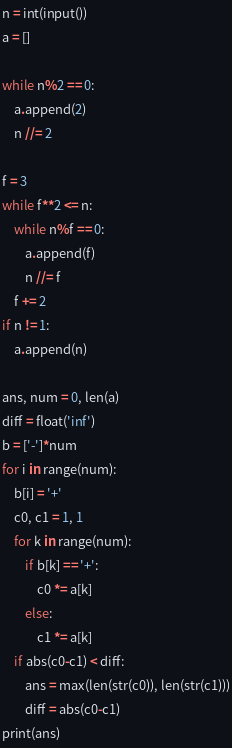<code> <loc_0><loc_0><loc_500><loc_500><_Python_>n = int(input())
a = []

while n%2 == 0:
    a.append(2)
    n //= 2

f = 3
while f**2 <= n:
    while n%f == 0:
        a.append(f)
        n //= f
    f += 2
if n != 1:
    a.append(n)

ans, num = 0, len(a)
diff = float('inf')
b = ['-']*num
for i in range(num):
    b[i] = '+'
    c0, c1 = 1, 1
    for k in range(num):
        if b[k] == '+':
            c0 *= a[k]
        else:
            c1 *= a[k]
    if abs(c0-c1) < diff:
        ans = max(len(str(c0)), len(str(c1)))
        diff = abs(c0-c1)
print(ans)
</code> 